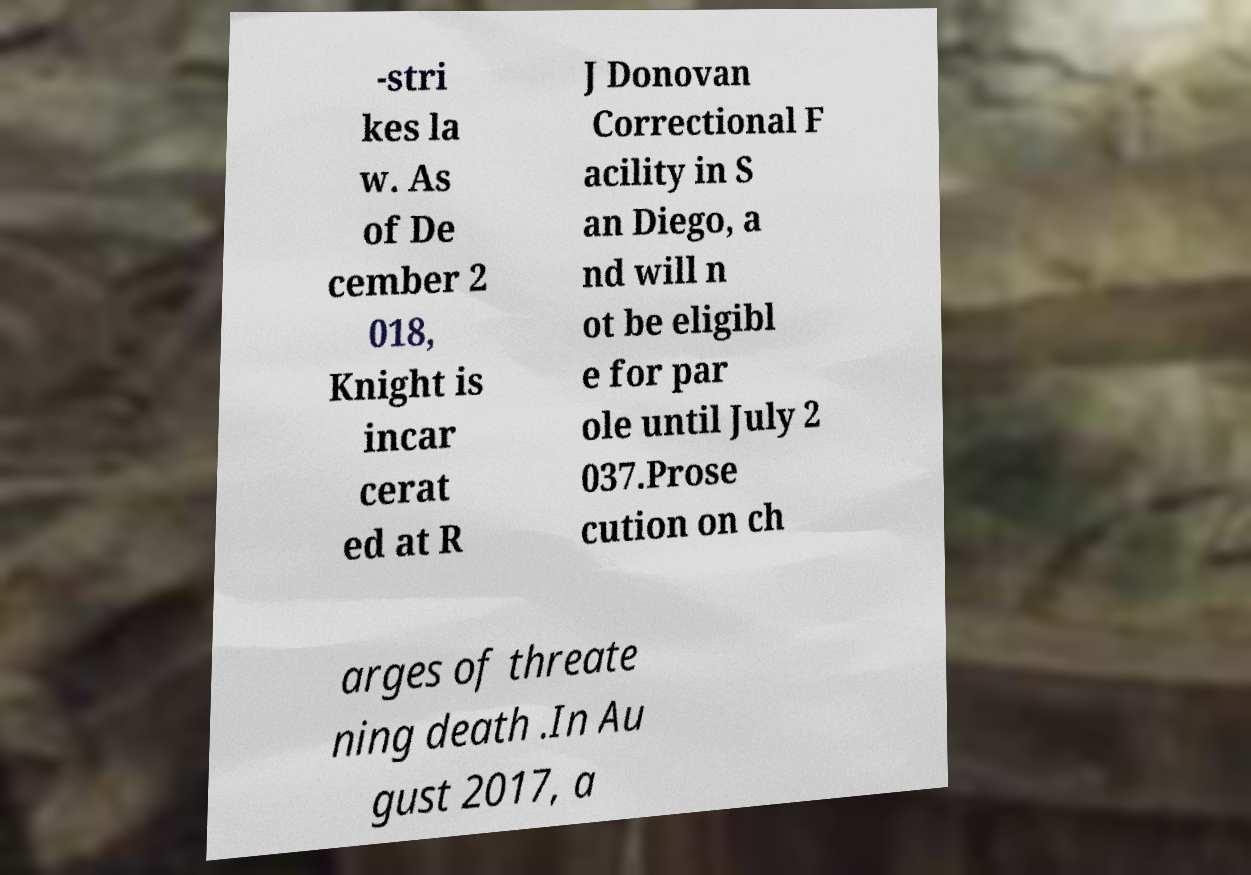Please read and relay the text visible in this image. What does it say? -stri kes la w. As of De cember 2 018, Knight is incar cerat ed at R J Donovan Correctional F acility in S an Diego, a nd will n ot be eligibl e for par ole until July 2 037.Prose cution on ch arges of threate ning death .In Au gust 2017, a 